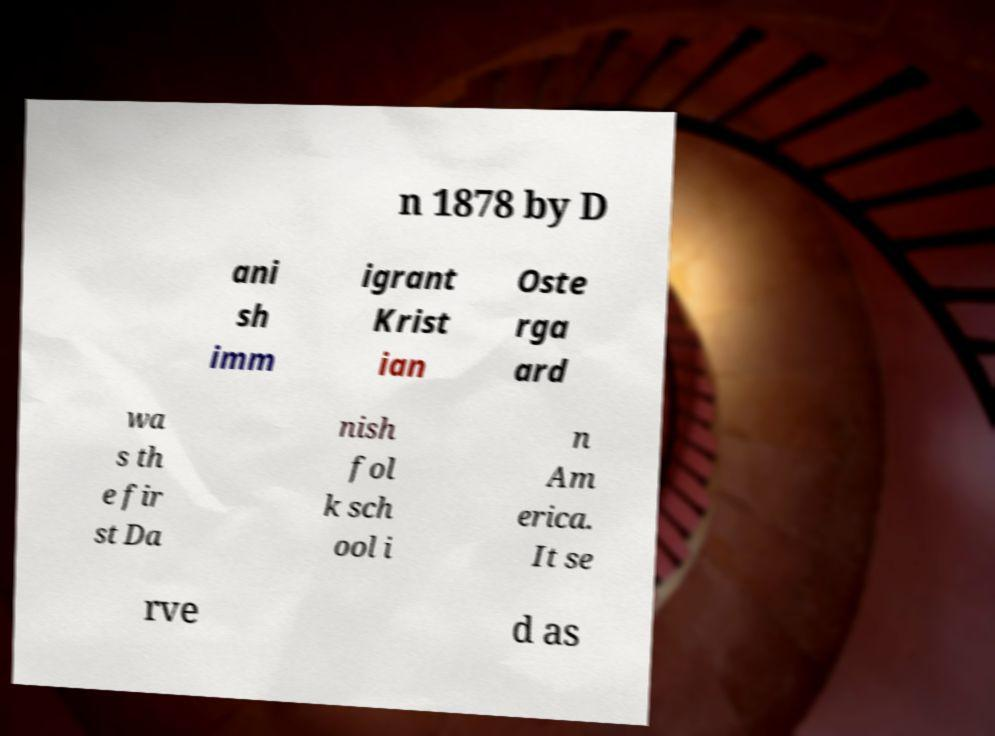For documentation purposes, I need the text within this image transcribed. Could you provide that? n 1878 by D ani sh imm igrant Krist ian Oste rga ard wa s th e fir st Da nish fol k sch ool i n Am erica. It se rve d as 